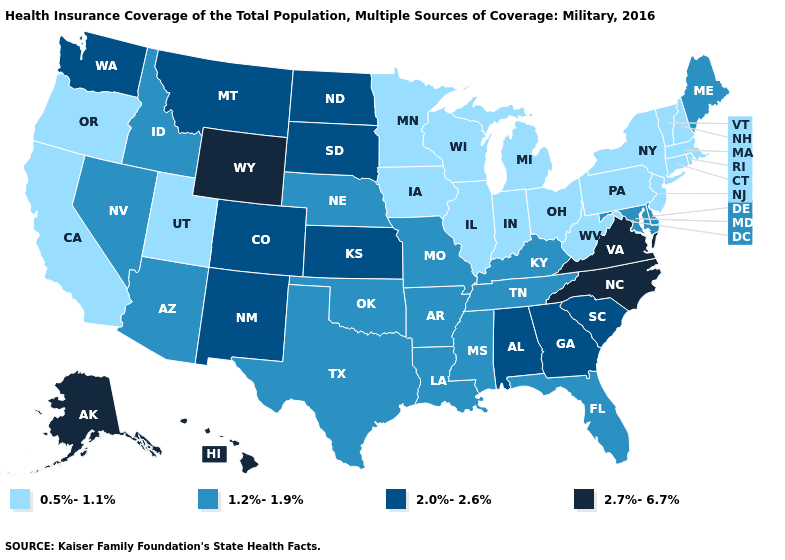How many symbols are there in the legend?
Write a very short answer. 4. Name the states that have a value in the range 1.2%-1.9%?
Keep it brief. Arizona, Arkansas, Delaware, Florida, Idaho, Kentucky, Louisiana, Maine, Maryland, Mississippi, Missouri, Nebraska, Nevada, Oklahoma, Tennessee, Texas. Which states have the lowest value in the USA?
Give a very brief answer. California, Connecticut, Illinois, Indiana, Iowa, Massachusetts, Michigan, Minnesota, New Hampshire, New Jersey, New York, Ohio, Oregon, Pennsylvania, Rhode Island, Utah, Vermont, West Virginia, Wisconsin. What is the value of Maryland?
Concise answer only. 1.2%-1.9%. Name the states that have a value in the range 2.0%-2.6%?
Keep it brief. Alabama, Colorado, Georgia, Kansas, Montana, New Mexico, North Dakota, South Carolina, South Dakota, Washington. What is the lowest value in states that border Georgia?
Concise answer only. 1.2%-1.9%. What is the value of Missouri?
Keep it brief. 1.2%-1.9%. Name the states that have a value in the range 1.2%-1.9%?
Give a very brief answer. Arizona, Arkansas, Delaware, Florida, Idaho, Kentucky, Louisiana, Maine, Maryland, Mississippi, Missouri, Nebraska, Nevada, Oklahoma, Tennessee, Texas. Does the map have missing data?
Be succinct. No. What is the value of Missouri?
Keep it brief. 1.2%-1.9%. Does Rhode Island have the lowest value in the Northeast?
Be succinct. Yes. What is the value of Massachusetts?
Give a very brief answer. 0.5%-1.1%. How many symbols are there in the legend?
Keep it brief. 4. 